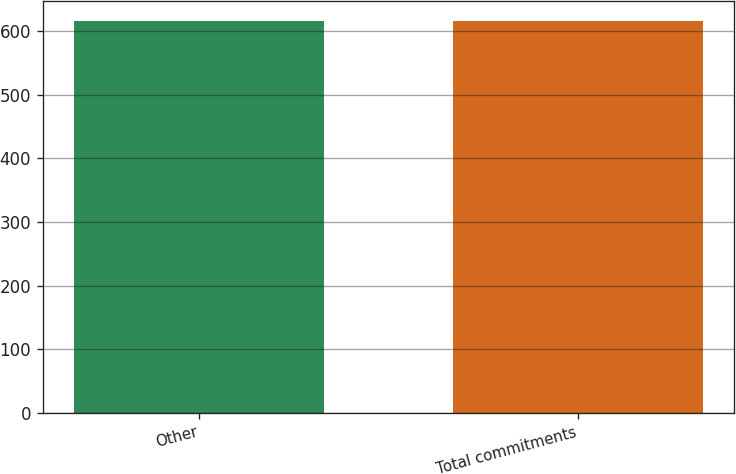Convert chart. <chart><loc_0><loc_0><loc_500><loc_500><bar_chart><fcel>Other<fcel>Total commitments<nl><fcel>616<fcel>616.1<nl></chart> 